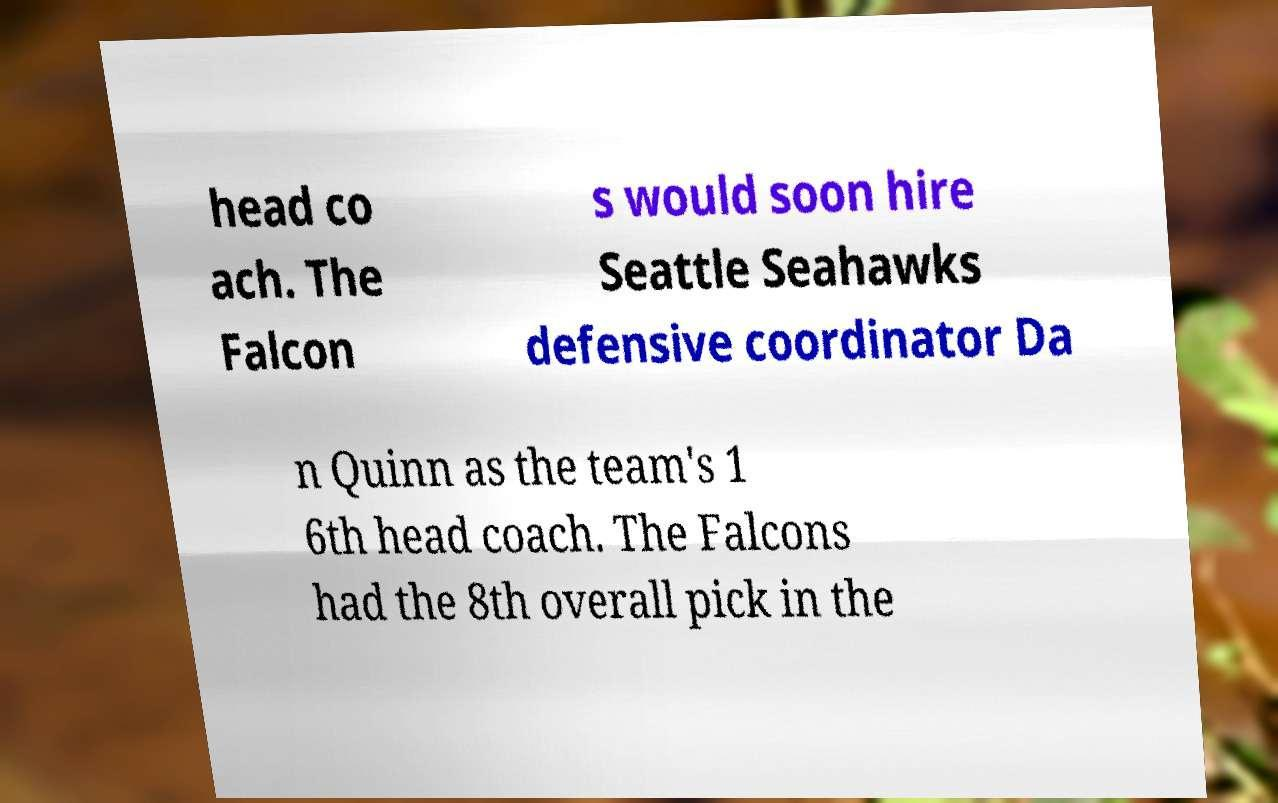I need the written content from this picture converted into text. Can you do that? head co ach. The Falcon s would soon hire Seattle Seahawks defensive coordinator Da n Quinn as the team's 1 6th head coach. The Falcons had the 8th overall pick in the 